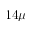Convert formula to latex. <formula><loc_0><loc_0><loc_500><loc_500>1 4 \mu</formula> 